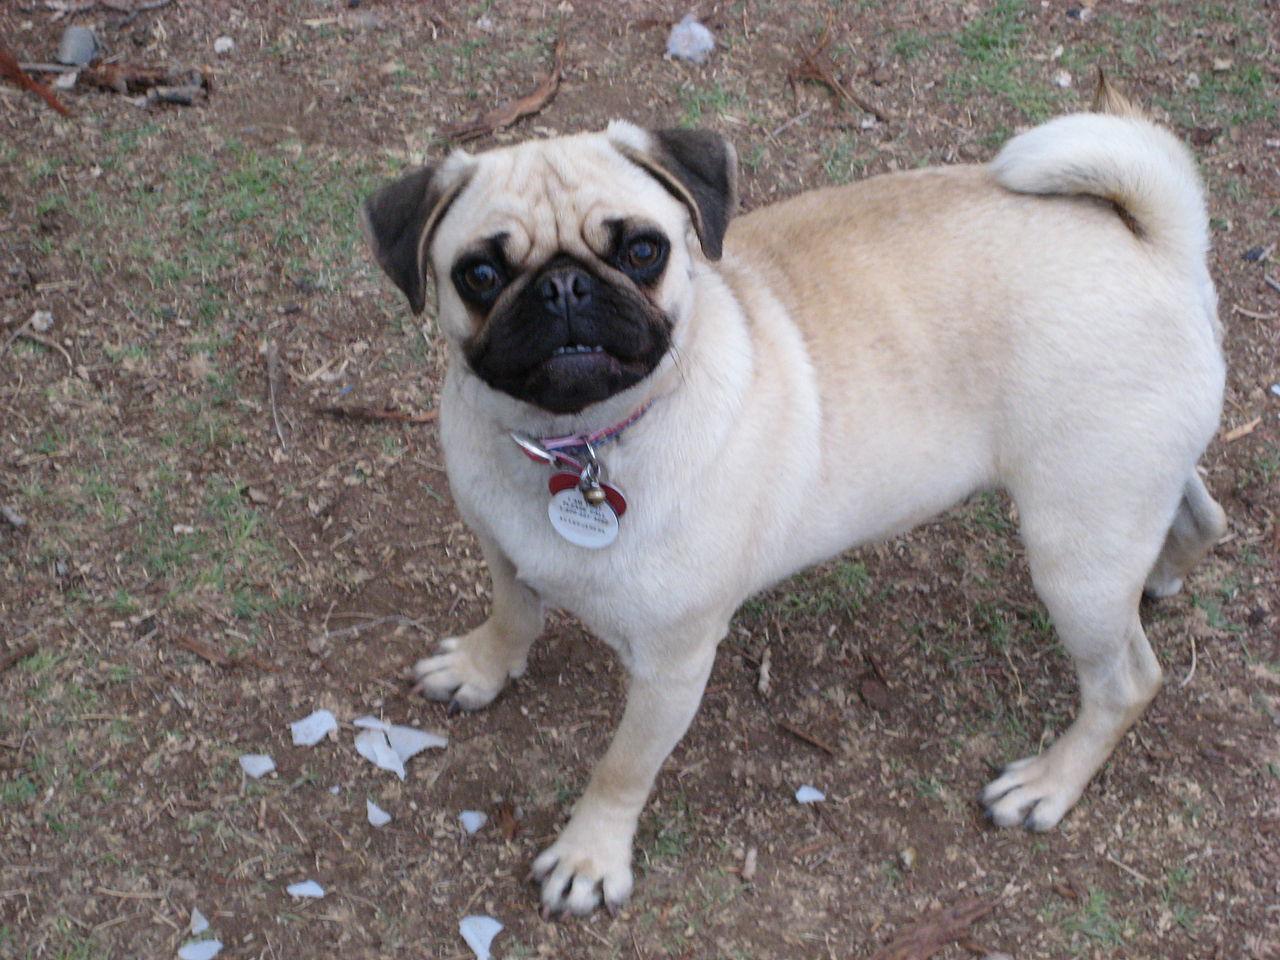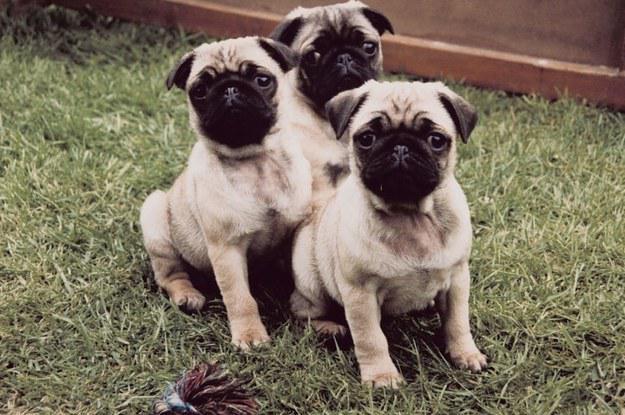The first image is the image on the left, the second image is the image on the right. For the images displayed, is the sentence "One of the paired images shows exactly four pug puppies." factually correct? Answer yes or no. No. 